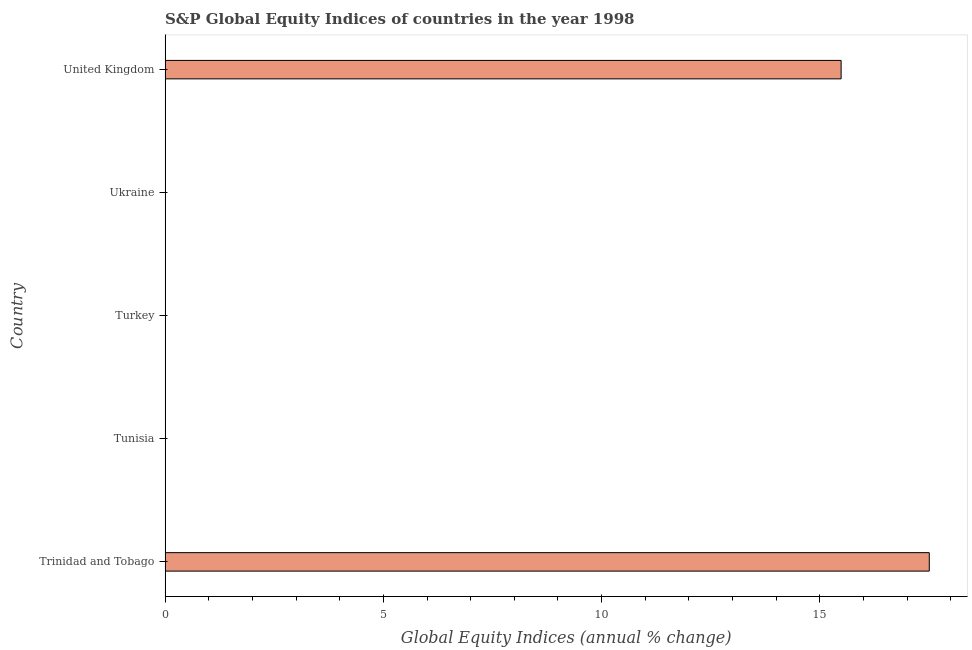Does the graph contain grids?
Provide a short and direct response. No. What is the title of the graph?
Make the answer very short. S&P Global Equity Indices of countries in the year 1998. What is the label or title of the X-axis?
Your answer should be compact. Global Equity Indices (annual % change). What is the label or title of the Y-axis?
Ensure brevity in your answer.  Country. What is the s&p global equity indices in United Kingdom?
Keep it short and to the point. 15.49. Across all countries, what is the maximum s&p global equity indices?
Make the answer very short. 17.51. In which country was the s&p global equity indices maximum?
Your answer should be very brief. Trinidad and Tobago. What is the sum of the s&p global equity indices?
Your answer should be compact. 32.99. What is the difference between the s&p global equity indices in Trinidad and Tobago and United Kingdom?
Your answer should be compact. 2.02. What is the average s&p global equity indices per country?
Your response must be concise. 6.6. In how many countries, is the s&p global equity indices greater than 14 %?
Your response must be concise. 2. Is the s&p global equity indices in Trinidad and Tobago less than that in United Kingdom?
Offer a terse response. No. What is the difference between the highest and the lowest s&p global equity indices?
Provide a succinct answer. 17.51. In how many countries, is the s&p global equity indices greater than the average s&p global equity indices taken over all countries?
Keep it short and to the point. 2. What is the difference between two consecutive major ticks on the X-axis?
Offer a very short reply. 5. Are the values on the major ticks of X-axis written in scientific E-notation?
Ensure brevity in your answer.  No. What is the Global Equity Indices (annual % change) in Trinidad and Tobago?
Give a very brief answer. 17.51. What is the Global Equity Indices (annual % change) in United Kingdom?
Offer a very short reply. 15.49. What is the difference between the Global Equity Indices (annual % change) in Trinidad and Tobago and United Kingdom?
Offer a terse response. 2.02. What is the ratio of the Global Equity Indices (annual % change) in Trinidad and Tobago to that in United Kingdom?
Provide a succinct answer. 1.13. 